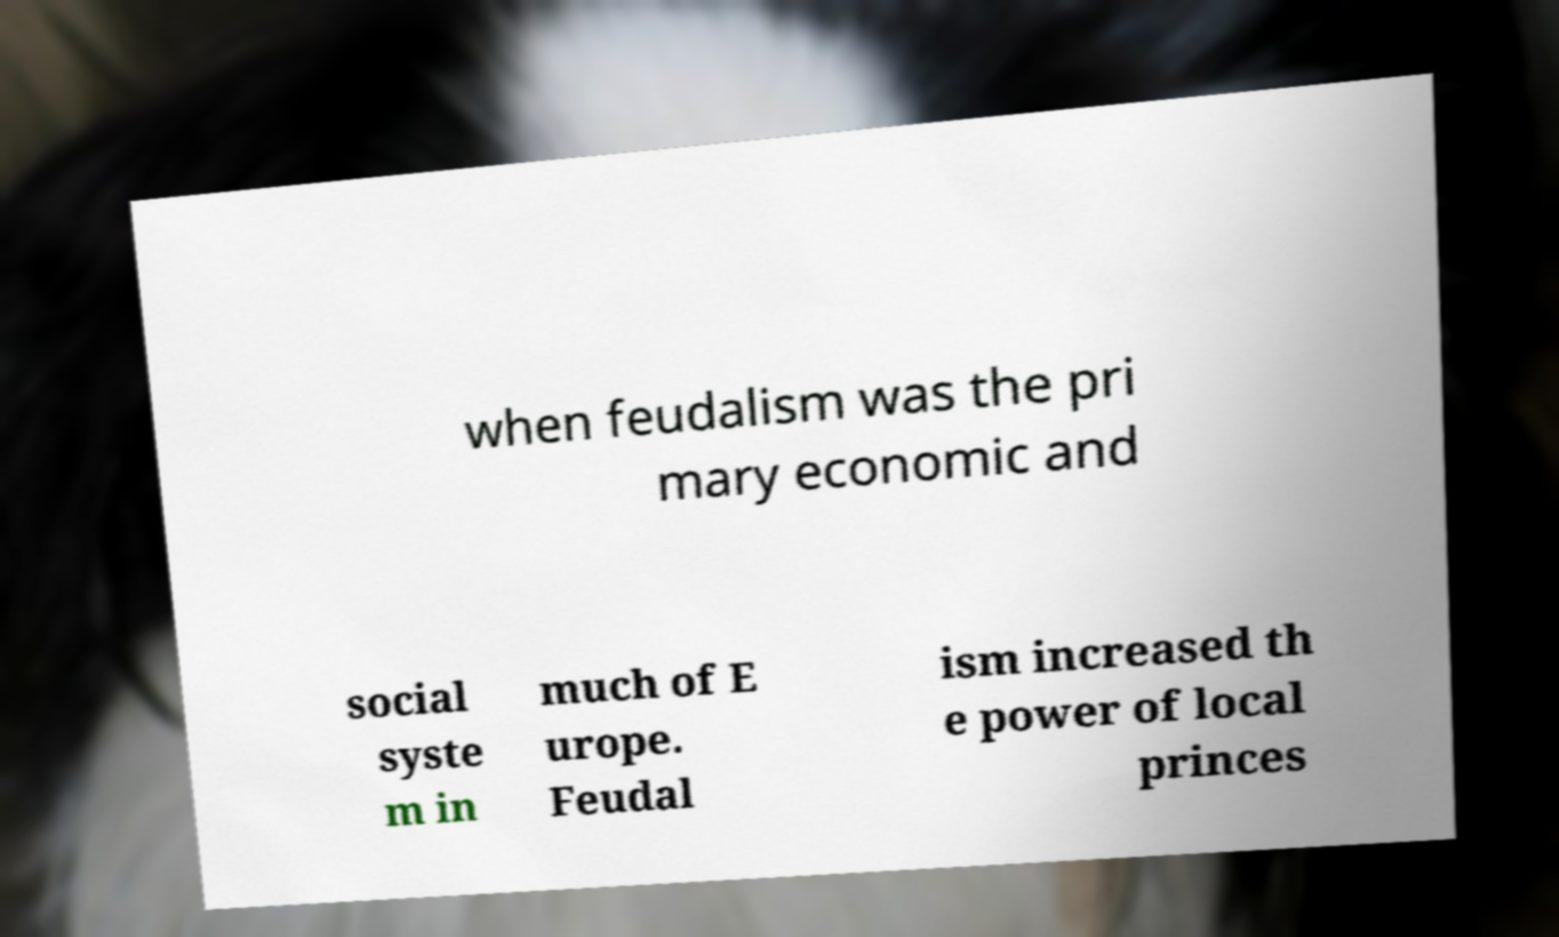Can you read and provide the text displayed in the image?This photo seems to have some interesting text. Can you extract and type it out for me? when feudalism was the pri mary economic and social syste m in much of E urope. Feudal ism increased th e power of local princes 